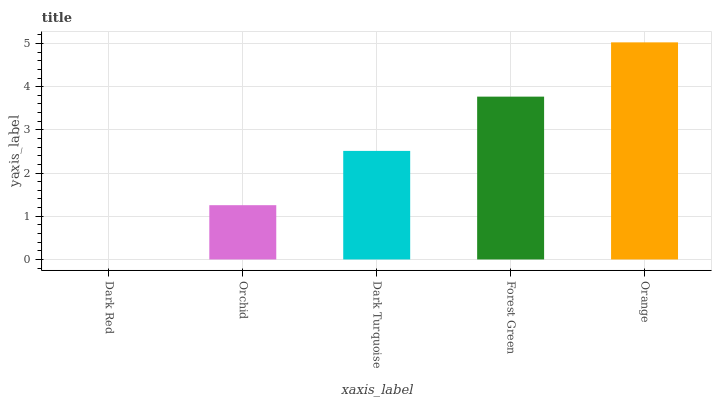Is Dark Red the minimum?
Answer yes or no. Yes. Is Orange the maximum?
Answer yes or no. Yes. Is Orchid the minimum?
Answer yes or no. No. Is Orchid the maximum?
Answer yes or no. No. Is Orchid greater than Dark Red?
Answer yes or no. Yes. Is Dark Red less than Orchid?
Answer yes or no. Yes. Is Dark Red greater than Orchid?
Answer yes or no. No. Is Orchid less than Dark Red?
Answer yes or no. No. Is Dark Turquoise the high median?
Answer yes or no. Yes. Is Dark Turquoise the low median?
Answer yes or no. Yes. Is Orchid the high median?
Answer yes or no. No. Is Forest Green the low median?
Answer yes or no. No. 